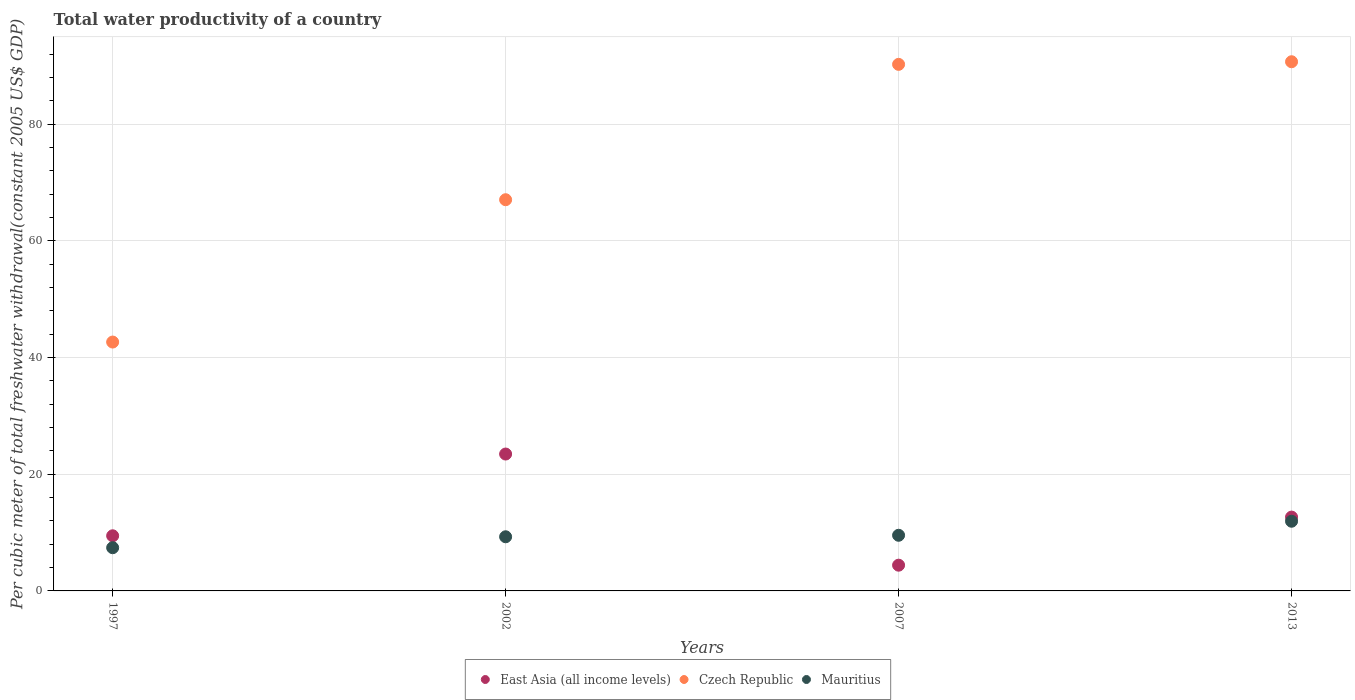What is the total water productivity in Czech Republic in 2002?
Provide a succinct answer. 67.07. Across all years, what is the maximum total water productivity in East Asia (all income levels)?
Provide a short and direct response. 23.47. Across all years, what is the minimum total water productivity in Mauritius?
Give a very brief answer. 7.41. What is the total total water productivity in Czech Republic in the graph?
Offer a terse response. 290.73. What is the difference between the total water productivity in Czech Republic in 2007 and that in 2013?
Provide a succinct answer. -0.45. What is the difference between the total water productivity in East Asia (all income levels) in 2002 and the total water productivity in Czech Republic in 1997?
Offer a very short reply. -19.2. What is the average total water productivity in East Asia (all income levels) per year?
Your answer should be very brief. 12.5. In the year 2013, what is the difference between the total water productivity in Czech Republic and total water productivity in East Asia (all income levels)?
Give a very brief answer. 78.07. In how many years, is the total water productivity in Mauritius greater than 12 US$?
Offer a terse response. 0. What is the ratio of the total water productivity in Mauritius in 2002 to that in 2013?
Provide a succinct answer. 0.78. What is the difference between the highest and the second highest total water productivity in East Asia (all income levels)?
Offer a terse response. 10.81. What is the difference between the highest and the lowest total water productivity in Mauritius?
Ensure brevity in your answer.  4.54. Is it the case that in every year, the sum of the total water productivity in East Asia (all income levels) and total water productivity in Mauritius  is greater than the total water productivity in Czech Republic?
Your response must be concise. No. What is the difference between two consecutive major ticks on the Y-axis?
Your answer should be compact. 20. Does the graph contain any zero values?
Your answer should be very brief. No. Does the graph contain grids?
Offer a very short reply. Yes. How many legend labels are there?
Offer a very short reply. 3. How are the legend labels stacked?
Provide a short and direct response. Horizontal. What is the title of the graph?
Offer a very short reply. Total water productivity of a country. Does "Tuvalu" appear as one of the legend labels in the graph?
Make the answer very short. No. What is the label or title of the Y-axis?
Give a very brief answer. Per cubic meter of total freshwater withdrawal(constant 2005 US$ GDP). What is the Per cubic meter of total freshwater withdrawal(constant 2005 US$ GDP) in East Asia (all income levels) in 1997?
Provide a succinct answer. 9.45. What is the Per cubic meter of total freshwater withdrawal(constant 2005 US$ GDP) in Czech Republic in 1997?
Offer a very short reply. 42.67. What is the Per cubic meter of total freshwater withdrawal(constant 2005 US$ GDP) in Mauritius in 1997?
Ensure brevity in your answer.  7.41. What is the Per cubic meter of total freshwater withdrawal(constant 2005 US$ GDP) in East Asia (all income levels) in 2002?
Provide a succinct answer. 23.47. What is the Per cubic meter of total freshwater withdrawal(constant 2005 US$ GDP) of Czech Republic in 2002?
Offer a very short reply. 67.07. What is the Per cubic meter of total freshwater withdrawal(constant 2005 US$ GDP) of Mauritius in 2002?
Keep it short and to the point. 9.28. What is the Per cubic meter of total freshwater withdrawal(constant 2005 US$ GDP) in East Asia (all income levels) in 2007?
Your answer should be very brief. 4.41. What is the Per cubic meter of total freshwater withdrawal(constant 2005 US$ GDP) of Czech Republic in 2007?
Offer a terse response. 90.28. What is the Per cubic meter of total freshwater withdrawal(constant 2005 US$ GDP) in Mauritius in 2007?
Your response must be concise. 9.54. What is the Per cubic meter of total freshwater withdrawal(constant 2005 US$ GDP) in East Asia (all income levels) in 2013?
Your answer should be compact. 12.66. What is the Per cubic meter of total freshwater withdrawal(constant 2005 US$ GDP) of Czech Republic in 2013?
Provide a short and direct response. 90.72. What is the Per cubic meter of total freshwater withdrawal(constant 2005 US$ GDP) of Mauritius in 2013?
Provide a succinct answer. 11.95. Across all years, what is the maximum Per cubic meter of total freshwater withdrawal(constant 2005 US$ GDP) in East Asia (all income levels)?
Your answer should be compact. 23.47. Across all years, what is the maximum Per cubic meter of total freshwater withdrawal(constant 2005 US$ GDP) of Czech Republic?
Offer a very short reply. 90.72. Across all years, what is the maximum Per cubic meter of total freshwater withdrawal(constant 2005 US$ GDP) of Mauritius?
Keep it short and to the point. 11.95. Across all years, what is the minimum Per cubic meter of total freshwater withdrawal(constant 2005 US$ GDP) of East Asia (all income levels)?
Provide a succinct answer. 4.41. Across all years, what is the minimum Per cubic meter of total freshwater withdrawal(constant 2005 US$ GDP) of Czech Republic?
Keep it short and to the point. 42.67. Across all years, what is the minimum Per cubic meter of total freshwater withdrawal(constant 2005 US$ GDP) in Mauritius?
Provide a short and direct response. 7.41. What is the total Per cubic meter of total freshwater withdrawal(constant 2005 US$ GDP) in East Asia (all income levels) in the graph?
Offer a terse response. 49.99. What is the total Per cubic meter of total freshwater withdrawal(constant 2005 US$ GDP) of Czech Republic in the graph?
Provide a short and direct response. 290.73. What is the total Per cubic meter of total freshwater withdrawal(constant 2005 US$ GDP) in Mauritius in the graph?
Offer a terse response. 38.18. What is the difference between the Per cubic meter of total freshwater withdrawal(constant 2005 US$ GDP) of East Asia (all income levels) in 1997 and that in 2002?
Provide a short and direct response. -14.02. What is the difference between the Per cubic meter of total freshwater withdrawal(constant 2005 US$ GDP) in Czech Republic in 1997 and that in 2002?
Your answer should be very brief. -24.4. What is the difference between the Per cubic meter of total freshwater withdrawal(constant 2005 US$ GDP) in Mauritius in 1997 and that in 2002?
Ensure brevity in your answer.  -1.87. What is the difference between the Per cubic meter of total freshwater withdrawal(constant 2005 US$ GDP) of East Asia (all income levels) in 1997 and that in 2007?
Your answer should be very brief. 5.04. What is the difference between the Per cubic meter of total freshwater withdrawal(constant 2005 US$ GDP) of Czech Republic in 1997 and that in 2007?
Give a very brief answer. -47.61. What is the difference between the Per cubic meter of total freshwater withdrawal(constant 2005 US$ GDP) in Mauritius in 1997 and that in 2007?
Your answer should be compact. -2.13. What is the difference between the Per cubic meter of total freshwater withdrawal(constant 2005 US$ GDP) of East Asia (all income levels) in 1997 and that in 2013?
Provide a short and direct response. -3.21. What is the difference between the Per cubic meter of total freshwater withdrawal(constant 2005 US$ GDP) of Czech Republic in 1997 and that in 2013?
Keep it short and to the point. -48.06. What is the difference between the Per cubic meter of total freshwater withdrawal(constant 2005 US$ GDP) in Mauritius in 1997 and that in 2013?
Your answer should be compact. -4.54. What is the difference between the Per cubic meter of total freshwater withdrawal(constant 2005 US$ GDP) in East Asia (all income levels) in 2002 and that in 2007?
Offer a very short reply. 19.06. What is the difference between the Per cubic meter of total freshwater withdrawal(constant 2005 US$ GDP) of Czech Republic in 2002 and that in 2007?
Offer a very short reply. -23.21. What is the difference between the Per cubic meter of total freshwater withdrawal(constant 2005 US$ GDP) of Mauritius in 2002 and that in 2007?
Keep it short and to the point. -0.26. What is the difference between the Per cubic meter of total freshwater withdrawal(constant 2005 US$ GDP) of East Asia (all income levels) in 2002 and that in 2013?
Your answer should be very brief. 10.81. What is the difference between the Per cubic meter of total freshwater withdrawal(constant 2005 US$ GDP) of Czech Republic in 2002 and that in 2013?
Keep it short and to the point. -23.65. What is the difference between the Per cubic meter of total freshwater withdrawal(constant 2005 US$ GDP) in Mauritius in 2002 and that in 2013?
Your answer should be very brief. -2.66. What is the difference between the Per cubic meter of total freshwater withdrawal(constant 2005 US$ GDP) in East Asia (all income levels) in 2007 and that in 2013?
Your answer should be very brief. -8.25. What is the difference between the Per cubic meter of total freshwater withdrawal(constant 2005 US$ GDP) of Czech Republic in 2007 and that in 2013?
Provide a succinct answer. -0.45. What is the difference between the Per cubic meter of total freshwater withdrawal(constant 2005 US$ GDP) in Mauritius in 2007 and that in 2013?
Keep it short and to the point. -2.41. What is the difference between the Per cubic meter of total freshwater withdrawal(constant 2005 US$ GDP) in East Asia (all income levels) in 1997 and the Per cubic meter of total freshwater withdrawal(constant 2005 US$ GDP) in Czech Republic in 2002?
Keep it short and to the point. -57.62. What is the difference between the Per cubic meter of total freshwater withdrawal(constant 2005 US$ GDP) of East Asia (all income levels) in 1997 and the Per cubic meter of total freshwater withdrawal(constant 2005 US$ GDP) of Mauritius in 2002?
Provide a short and direct response. 0.17. What is the difference between the Per cubic meter of total freshwater withdrawal(constant 2005 US$ GDP) of Czech Republic in 1997 and the Per cubic meter of total freshwater withdrawal(constant 2005 US$ GDP) of Mauritius in 2002?
Give a very brief answer. 33.38. What is the difference between the Per cubic meter of total freshwater withdrawal(constant 2005 US$ GDP) of East Asia (all income levels) in 1997 and the Per cubic meter of total freshwater withdrawal(constant 2005 US$ GDP) of Czech Republic in 2007?
Keep it short and to the point. -80.82. What is the difference between the Per cubic meter of total freshwater withdrawal(constant 2005 US$ GDP) of East Asia (all income levels) in 1997 and the Per cubic meter of total freshwater withdrawal(constant 2005 US$ GDP) of Mauritius in 2007?
Provide a succinct answer. -0.09. What is the difference between the Per cubic meter of total freshwater withdrawal(constant 2005 US$ GDP) of Czech Republic in 1997 and the Per cubic meter of total freshwater withdrawal(constant 2005 US$ GDP) of Mauritius in 2007?
Give a very brief answer. 33.13. What is the difference between the Per cubic meter of total freshwater withdrawal(constant 2005 US$ GDP) of East Asia (all income levels) in 1997 and the Per cubic meter of total freshwater withdrawal(constant 2005 US$ GDP) of Czech Republic in 2013?
Your response must be concise. -81.27. What is the difference between the Per cubic meter of total freshwater withdrawal(constant 2005 US$ GDP) in East Asia (all income levels) in 1997 and the Per cubic meter of total freshwater withdrawal(constant 2005 US$ GDP) in Mauritius in 2013?
Offer a very short reply. -2.5. What is the difference between the Per cubic meter of total freshwater withdrawal(constant 2005 US$ GDP) in Czech Republic in 1997 and the Per cubic meter of total freshwater withdrawal(constant 2005 US$ GDP) in Mauritius in 2013?
Your answer should be very brief. 30.72. What is the difference between the Per cubic meter of total freshwater withdrawal(constant 2005 US$ GDP) of East Asia (all income levels) in 2002 and the Per cubic meter of total freshwater withdrawal(constant 2005 US$ GDP) of Czech Republic in 2007?
Provide a short and direct response. -66.81. What is the difference between the Per cubic meter of total freshwater withdrawal(constant 2005 US$ GDP) in East Asia (all income levels) in 2002 and the Per cubic meter of total freshwater withdrawal(constant 2005 US$ GDP) in Mauritius in 2007?
Make the answer very short. 13.93. What is the difference between the Per cubic meter of total freshwater withdrawal(constant 2005 US$ GDP) in Czech Republic in 2002 and the Per cubic meter of total freshwater withdrawal(constant 2005 US$ GDP) in Mauritius in 2007?
Offer a very short reply. 57.53. What is the difference between the Per cubic meter of total freshwater withdrawal(constant 2005 US$ GDP) in East Asia (all income levels) in 2002 and the Per cubic meter of total freshwater withdrawal(constant 2005 US$ GDP) in Czech Republic in 2013?
Ensure brevity in your answer.  -67.25. What is the difference between the Per cubic meter of total freshwater withdrawal(constant 2005 US$ GDP) of East Asia (all income levels) in 2002 and the Per cubic meter of total freshwater withdrawal(constant 2005 US$ GDP) of Mauritius in 2013?
Your response must be concise. 11.52. What is the difference between the Per cubic meter of total freshwater withdrawal(constant 2005 US$ GDP) in Czech Republic in 2002 and the Per cubic meter of total freshwater withdrawal(constant 2005 US$ GDP) in Mauritius in 2013?
Keep it short and to the point. 55.12. What is the difference between the Per cubic meter of total freshwater withdrawal(constant 2005 US$ GDP) in East Asia (all income levels) in 2007 and the Per cubic meter of total freshwater withdrawal(constant 2005 US$ GDP) in Czech Republic in 2013?
Give a very brief answer. -86.31. What is the difference between the Per cubic meter of total freshwater withdrawal(constant 2005 US$ GDP) in East Asia (all income levels) in 2007 and the Per cubic meter of total freshwater withdrawal(constant 2005 US$ GDP) in Mauritius in 2013?
Offer a very short reply. -7.54. What is the difference between the Per cubic meter of total freshwater withdrawal(constant 2005 US$ GDP) in Czech Republic in 2007 and the Per cubic meter of total freshwater withdrawal(constant 2005 US$ GDP) in Mauritius in 2013?
Your response must be concise. 78.33. What is the average Per cubic meter of total freshwater withdrawal(constant 2005 US$ GDP) of East Asia (all income levels) per year?
Make the answer very short. 12.5. What is the average Per cubic meter of total freshwater withdrawal(constant 2005 US$ GDP) of Czech Republic per year?
Provide a short and direct response. 72.68. What is the average Per cubic meter of total freshwater withdrawal(constant 2005 US$ GDP) in Mauritius per year?
Give a very brief answer. 9.54. In the year 1997, what is the difference between the Per cubic meter of total freshwater withdrawal(constant 2005 US$ GDP) of East Asia (all income levels) and Per cubic meter of total freshwater withdrawal(constant 2005 US$ GDP) of Czech Republic?
Keep it short and to the point. -33.22. In the year 1997, what is the difference between the Per cubic meter of total freshwater withdrawal(constant 2005 US$ GDP) in East Asia (all income levels) and Per cubic meter of total freshwater withdrawal(constant 2005 US$ GDP) in Mauritius?
Ensure brevity in your answer.  2.04. In the year 1997, what is the difference between the Per cubic meter of total freshwater withdrawal(constant 2005 US$ GDP) in Czech Republic and Per cubic meter of total freshwater withdrawal(constant 2005 US$ GDP) in Mauritius?
Give a very brief answer. 35.26. In the year 2002, what is the difference between the Per cubic meter of total freshwater withdrawal(constant 2005 US$ GDP) of East Asia (all income levels) and Per cubic meter of total freshwater withdrawal(constant 2005 US$ GDP) of Czech Republic?
Make the answer very short. -43.6. In the year 2002, what is the difference between the Per cubic meter of total freshwater withdrawal(constant 2005 US$ GDP) of East Asia (all income levels) and Per cubic meter of total freshwater withdrawal(constant 2005 US$ GDP) of Mauritius?
Provide a succinct answer. 14.19. In the year 2002, what is the difference between the Per cubic meter of total freshwater withdrawal(constant 2005 US$ GDP) of Czech Republic and Per cubic meter of total freshwater withdrawal(constant 2005 US$ GDP) of Mauritius?
Provide a short and direct response. 57.79. In the year 2007, what is the difference between the Per cubic meter of total freshwater withdrawal(constant 2005 US$ GDP) of East Asia (all income levels) and Per cubic meter of total freshwater withdrawal(constant 2005 US$ GDP) of Czech Republic?
Your answer should be compact. -85.86. In the year 2007, what is the difference between the Per cubic meter of total freshwater withdrawal(constant 2005 US$ GDP) of East Asia (all income levels) and Per cubic meter of total freshwater withdrawal(constant 2005 US$ GDP) of Mauritius?
Your answer should be very brief. -5.13. In the year 2007, what is the difference between the Per cubic meter of total freshwater withdrawal(constant 2005 US$ GDP) in Czech Republic and Per cubic meter of total freshwater withdrawal(constant 2005 US$ GDP) in Mauritius?
Give a very brief answer. 80.74. In the year 2013, what is the difference between the Per cubic meter of total freshwater withdrawal(constant 2005 US$ GDP) of East Asia (all income levels) and Per cubic meter of total freshwater withdrawal(constant 2005 US$ GDP) of Czech Republic?
Ensure brevity in your answer.  -78.07. In the year 2013, what is the difference between the Per cubic meter of total freshwater withdrawal(constant 2005 US$ GDP) in East Asia (all income levels) and Per cubic meter of total freshwater withdrawal(constant 2005 US$ GDP) in Mauritius?
Your answer should be compact. 0.71. In the year 2013, what is the difference between the Per cubic meter of total freshwater withdrawal(constant 2005 US$ GDP) in Czech Republic and Per cubic meter of total freshwater withdrawal(constant 2005 US$ GDP) in Mauritius?
Your answer should be compact. 78.78. What is the ratio of the Per cubic meter of total freshwater withdrawal(constant 2005 US$ GDP) in East Asia (all income levels) in 1997 to that in 2002?
Make the answer very short. 0.4. What is the ratio of the Per cubic meter of total freshwater withdrawal(constant 2005 US$ GDP) of Czech Republic in 1997 to that in 2002?
Give a very brief answer. 0.64. What is the ratio of the Per cubic meter of total freshwater withdrawal(constant 2005 US$ GDP) in Mauritius in 1997 to that in 2002?
Give a very brief answer. 0.8. What is the ratio of the Per cubic meter of total freshwater withdrawal(constant 2005 US$ GDP) in East Asia (all income levels) in 1997 to that in 2007?
Your answer should be very brief. 2.14. What is the ratio of the Per cubic meter of total freshwater withdrawal(constant 2005 US$ GDP) in Czech Republic in 1997 to that in 2007?
Keep it short and to the point. 0.47. What is the ratio of the Per cubic meter of total freshwater withdrawal(constant 2005 US$ GDP) of Mauritius in 1997 to that in 2007?
Your response must be concise. 0.78. What is the ratio of the Per cubic meter of total freshwater withdrawal(constant 2005 US$ GDP) in East Asia (all income levels) in 1997 to that in 2013?
Your answer should be very brief. 0.75. What is the ratio of the Per cubic meter of total freshwater withdrawal(constant 2005 US$ GDP) of Czech Republic in 1997 to that in 2013?
Your answer should be compact. 0.47. What is the ratio of the Per cubic meter of total freshwater withdrawal(constant 2005 US$ GDP) of Mauritius in 1997 to that in 2013?
Provide a short and direct response. 0.62. What is the ratio of the Per cubic meter of total freshwater withdrawal(constant 2005 US$ GDP) of East Asia (all income levels) in 2002 to that in 2007?
Provide a succinct answer. 5.32. What is the ratio of the Per cubic meter of total freshwater withdrawal(constant 2005 US$ GDP) in Czech Republic in 2002 to that in 2007?
Make the answer very short. 0.74. What is the ratio of the Per cubic meter of total freshwater withdrawal(constant 2005 US$ GDP) in Mauritius in 2002 to that in 2007?
Your response must be concise. 0.97. What is the ratio of the Per cubic meter of total freshwater withdrawal(constant 2005 US$ GDP) in East Asia (all income levels) in 2002 to that in 2013?
Give a very brief answer. 1.85. What is the ratio of the Per cubic meter of total freshwater withdrawal(constant 2005 US$ GDP) in Czech Republic in 2002 to that in 2013?
Ensure brevity in your answer.  0.74. What is the ratio of the Per cubic meter of total freshwater withdrawal(constant 2005 US$ GDP) of Mauritius in 2002 to that in 2013?
Your answer should be very brief. 0.78. What is the ratio of the Per cubic meter of total freshwater withdrawal(constant 2005 US$ GDP) in East Asia (all income levels) in 2007 to that in 2013?
Offer a terse response. 0.35. What is the ratio of the Per cubic meter of total freshwater withdrawal(constant 2005 US$ GDP) of Mauritius in 2007 to that in 2013?
Give a very brief answer. 0.8. What is the difference between the highest and the second highest Per cubic meter of total freshwater withdrawal(constant 2005 US$ GDP) of East Asia (all income levels)?
Keep it short and to the point. 10.81. What is the difference between the highest and the second highest Per cubic meter of total freshwater withdrawal(constant 2005 US$ GDP) of Czech Republic?
Give a very brief answer. 0.45. What is the difference between the highest and the second highest Per cubic meter of total freshwater withdrawal(constant 2005 US$ GDP) in Mauritius?
Keep it short and to the point. 2.41. What is the difference between the highest and the lowest Per cubic meter of total freshwater withdrawal(constant 2005 US$ GDP) in East Asia (all income levels)?
Make the answer very short. 19.06. What is the difference between the highest and the lowest Per cubic meter of total freshwater withdrawal(constant 2005 US$ GDP) in Czech Republic?
Provide a succinct answer. 48.06. What is the difference between the highest and the lowest Per cubic meter of total freshwater withdrawal(constant 2005 US$ GDP) of Mauritius?
Offer a terse response. 4.54. 